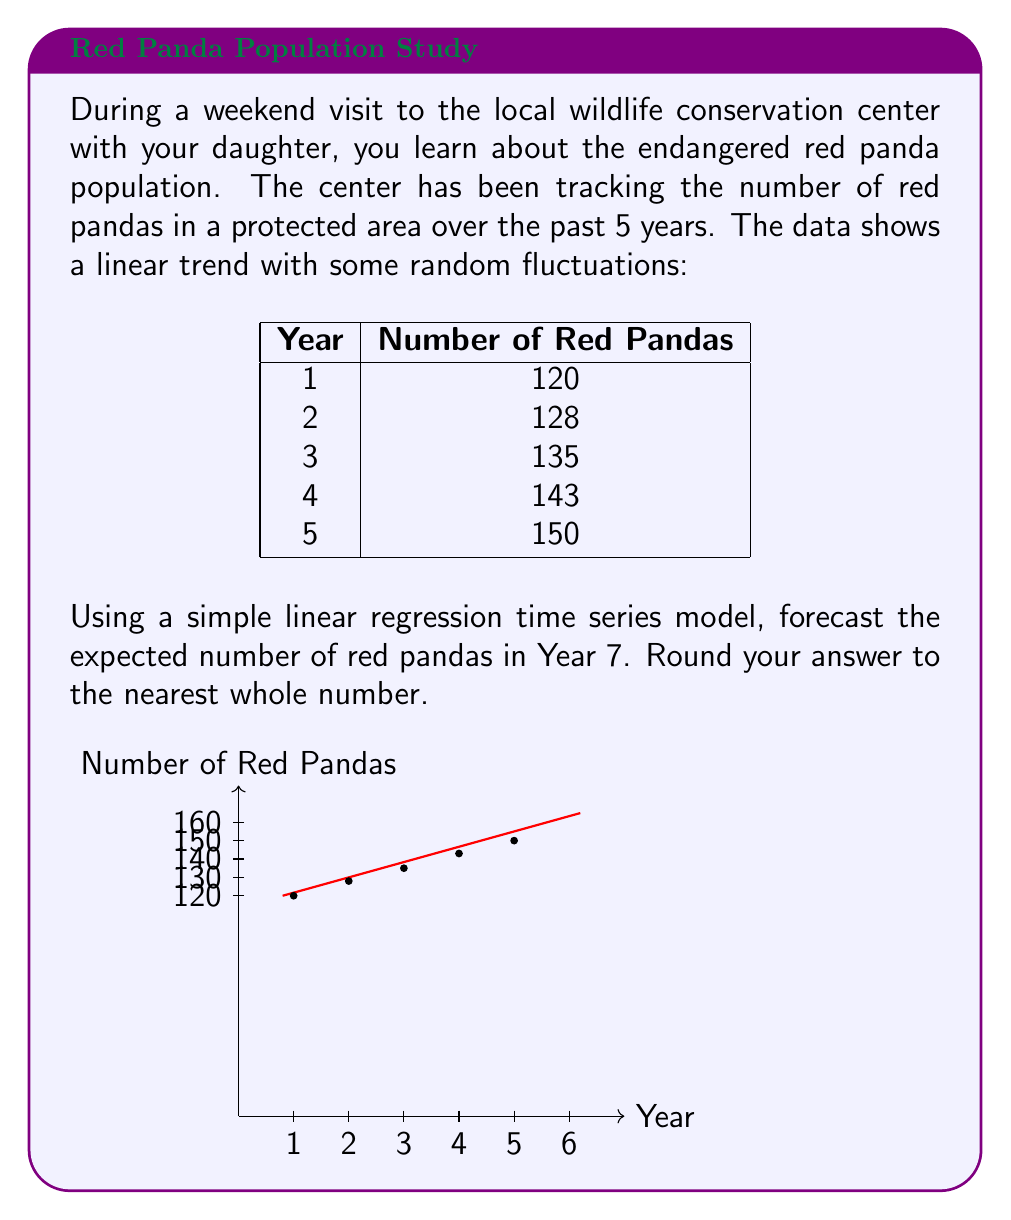Teach me how to tackle this problem. To forecast the red panda population using a simple linear regression time series model, we'll follow these steps:

1) The linear regression model has the form:
   $$ Y_t = \beta_0 + \beta_1 t + \epsilon_t $$
   where $Y_t$ is the population at time $t$, $\beta_0$ is the y-intercept, $\beta_1$ is the slope, and $\epsilon_t$ is the error term.

2) To find $\beta_0$ and $\beta_1$, we can use the following formulas:
   $$ \beta_1 = \frac{n\sum{ty} - \sum{t}\sum{y}}{n\sum{t^2} - (\sum{t})^2} $$
   $$ \beta_0 = \bar{y} - \beta_1\bar{t} $$

3) Calculate the means:
   $\bar{t} = (1+2+3+4+5)/5 = 3$
   $\bar{y} = (120+128+135+143+150)/5 = 135.2$

4) Calculate $\beta_1$:
   $$ \beta_1 = \frac{5(1*120 + 2*128 + 3*135 + 4*143 + 5*150) - (15)(676)}{5(55) - (15)^2} = 7.4 $$

5) Calculate $\beta_0$:
   $$ \beta_0 = 135.2 - 7.4(3) = 112.6 $$

6) Our model is:
   $$ Y_t = 112.6 + 7.4t $$

7) To forecast Year 7, we substitute $t=7$:
   $$ Y_7 = 112.6 + 7.4(7) = 164.4 $$

8) Rounding to the nearest whole number: 164
Answer: 164 